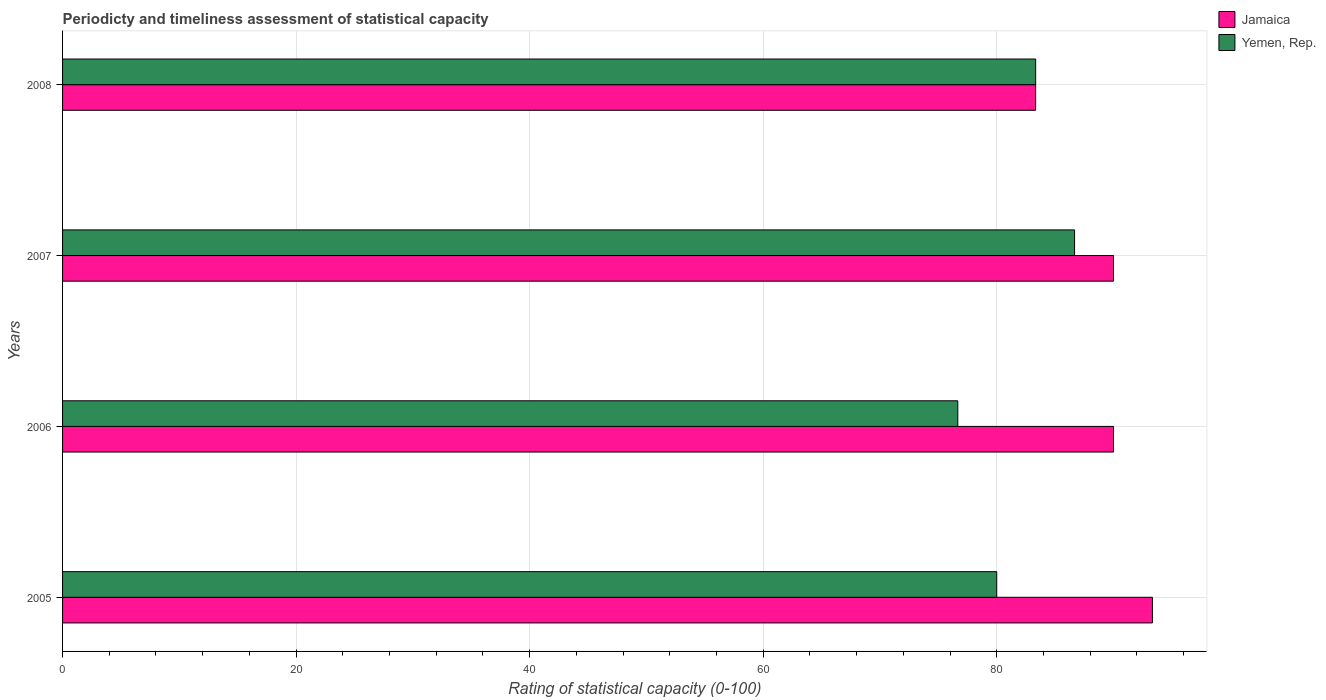How many different coloured bars are there?
Give a very brief answer. 2. How many groups of bars are there?
Provide a succinct answer. 4. Are the number of bars per tick equal to the number of legend labels?
Provide a succinct answer. Yes. Are the number of bars on each tick of the Y-axis equal?
Your response must be concise. Yes. How many bars are there on the 3rd tick from the bottom?
Your answer should be compact. 2. What is the label of the 2nd group of bars from the top?
Your response must be concise. 2007. What is the rating of statistical capacity in Yemen, Rep. in 2006?
Offer a very short reply. 76.67. Across all years, what is the maximum rating of statistical capacity in Jamaica?
Make the answer very short. 93.33. Across all years, what is the minimum rating of statistical capacity in Yemen, Rep.?
Keep it short and to the point. 76.67. What is the total rating of statistical capacity in Yemen, Rep. in the graph?
Keep it short and to the point. 326.67. What is the difference between the rating of statistical capacity in Jamaica in 2005 and that in 2006?
Make the answer very short. 3.33. What is the difference between the rating of statistical capacity in Jamaica in 2008 and the rating of statistical capacity in Yemen, Rep. in 2007?
Provide a short and direct response. -3.33. What is the average rating of statistical capacity in Jamaica per year?
Keep it short and to the point. 89.17. What is the ratio of the rating of statistical capacity in Jamaica in 2005 to that in 2008?
Ensure brevity in your answer.  1.12. Is the rating of statistical capacity in Yemen, Rep. in 2005 less than that in 2008?
Give a very brief answer. Yes. What is the difference between the highest and the second highest rating of statistical capacity in Yemen, Rep.?
Your response must be concise. 3.33. What is the difference between the highest and the lowest rating of statistical capacity in Yemen, Rep.?
Your response must be concise. 10. What does the 1st bar from the top in 2005 represents?
Offer a very short reply. Yemen, Rep. What does the 2nd bar from the bottom in 2008 represents?
Your response must be concise. Yemen, Rep. Are all the bars in the graph horizontal?
Your answer should be very brief. Yes. How many years are there in the graph?
Make the answer very short. 4. Are the values on the major ticks of X-axis written in scientific E-notation?
Make the answer very short. No. Does the graph contain any zero values?
Your response must be concise. No. Does the graph contain grids?
Your answer should be very brief. Yes. What is the title of the graph?
Provide a succinct answer. Periodicty and timeliness assessment of statistical capacity. What is the label or title of the X-axis?
Your answer should be compact. Rating of statistical capacity (0-100). What is the label or title of the Y-axis?
Offer a terse response. Years. What is the Rating of statistical capacity (0-100) in Jamaica in 2005?
Provide a short and direct response. 93.33. What is the Rating of statistical capacity (0-100) of Jamaica in 2006?
Your answer should be very brief. 90. What is the Rating of statistical capacity (0-100) of Yemen, Rep. in 2006?
Offer a very short reply. 76.67. What is the Rating of statistical capacity (0-100) in Jamaica in 2007?
Offer a very short reply. 90. What is the Rating of statistical capacity (0-100) in Yemen, Rep. in 2007?
Make the answer very short. 86.67. What is the Rating of statistical capacity (0-100) of Jamaica in 2008?
Keep it short and to the point. 83.33. What is the Rating of statistical capacity (0-100) in Yemen, Rep. in 2008?
Offer a very short reply. 83.33. Across all years, what is the maximum Rating of statistical capacity (0-100) in Jamaica?
Keep it short and to the point. 93.33. Across all years, what is the maximum Rating of statistical capacity (0-100) in Yemen, Rep.?
Your response must be concise. 86.67. Across all years, what is the minimum Rating of statistical capacity (0-100) in Jamaica?
Your response must be concise. 83.33. Across all years, what is the minimum Rating of statistical capacity (0-100) of Yemen, Rep.?
Keep it short and to the point. 76.67. What is the total Rating of statistical capacity (0-100) of Jamaica in the graph?
Your response must be concise. 356.67. What is the total Rating of statistical capacity (0-100) of Yemen, Rep. in the graph?
Your answer should be very brief. 326.67. What is the difference between the Rating of statistical capacity (0-100) of Jamaica in 2005 and that in 2007?
Ensure brevity in your answer.  3.33. What is the difference between the Rating of statistical capacity (0-100) in Yemen, Rep. in 2005 and that in 2007?
Your response must be concise. -6.67. What is the difference between the Rating of statistical capacity (0-100) of Jamaica in 2005 and that in 2008?
Offer a very short reply. 10. What is the difference between the Rating of statistical capacity (0-100) of Yemen, Rep. in 2005 and that in 2008?
Your response must be concise. -3.33. What is the difference between the Rating of statistical capacity (0-100) of Yemen, Rep. in 2006 and that in 2007?
Your response must be concise. -10. What is the difference between the Rating of statistical capacity (0-100) of Jamaica in 2006 and that in 2008?
Your answer should be compact. 6.67. What is the difference between the Rating of statistical capacity (0-100) in Yemen, Rep. in 2006 and that in 2008?
Your answer should be compact. -6.67. What is the difference between the Rating of statistical capacity (0-100) of Jamaica in 2005 and the Rating of statistical capacity (0-100) of Yemen, Rep. in 2006?
Your answer should be very brief. 16.67. What is the difference between the Rating of statistical capacity (0-100) in Jamaica in 2006 and the Rating of statistical capacity (0-100) in Yemen, Rep. in 2007?
Your answer should be very brief. 3.33. What is the difference between the Rating of statistical capacity (0-100) in Jamaica in 2006 and the Rating of statistical capacity (0-100) in Yemen, Rep. in 2008?
Make the answer very short. 6.67. What is the average Rating of statistical capacity (0-100) of Jamaica per year?
Give a very brief answer. 89.17. What is the average Rating of statistical capacity (0-100) in Yemen, Rep. per year?
Offer a terse response. 81.67. In the year 2005, what is the difference between the Rating of statistical capacity (0-100) of Jamaica and Rating of statistical capacity (0-100) of Yemen, Rep.?
Provide a short and direct response. 13.33. In the year 2006, what is the difference between the Rating of statistical capacity (0-100) in Jamaica and Rating of statistical capacity (0-100) in Yemen, Rep.?
Make the answer very short. 13.33. In the year 2007, what is the difference between the Rating of statistical capacity (0-100) in Jamaica and Rating of statistical capacity (0-100) in Yemen, Rep.?
Ensure brevity in your answer.  3.33. What is the ratio of the Rating of statistical capacity (0-100) in Yemen, Rep. in 2005 to that in 2006?
Offer a terse response. 1.04. What is the ratio of the Rating of statistical capacity (0-100) of Jamaica in 2005 to that in 2008?
Your response must be concise. 1.12. What is the ratio of the Rating of statistical capacity (0-100) of Jamaica in 2006 to that in 2007?
Ensure brevity in your answer.  1. What is the ratio of the Rating of statistical capacity (0-100) of Yemen, Rep. in 2006 to that in 2007?
Offer a terse response. 0.88. What is the ratio of the Rating of statistical capacity (0-100) in Jamaica in 2006 to that in 2008?
Make the answer very short. 1.08. What is the ratio of the Rating of statistical capacity (0-100) of Jamaica in 2007 to that in 2008?
Your answer should be very brief. 1.08. What is the difference between the highest and the second highest Rating of statistical capacity (0-100) of Jamaica?
Keep it short and to the point. 3.33. What is the difference between the highest and the second highest Rating of statistical capacity (0-100) in Yemen, Rep.?
Provide a short and direct response. 3.33. What is the difference between the highest and the lowest Rating of statistical capacity (0-100) in Yemen, Rep.?
Provide a short and direct response. 10. 